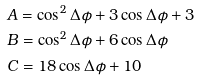<formula> <loc_0><loc_0><loc_500><loc_500>& A = \cos ^ { 2 } \Delta \phi + 3 \cos \Delta \phi + 3 \\ & B = \cos ^ { 2 } \Delta \phi + 6 \cos \Delta \phi \\ & C = 1 8 \cos \Delta \phi + 1 0</formula> 